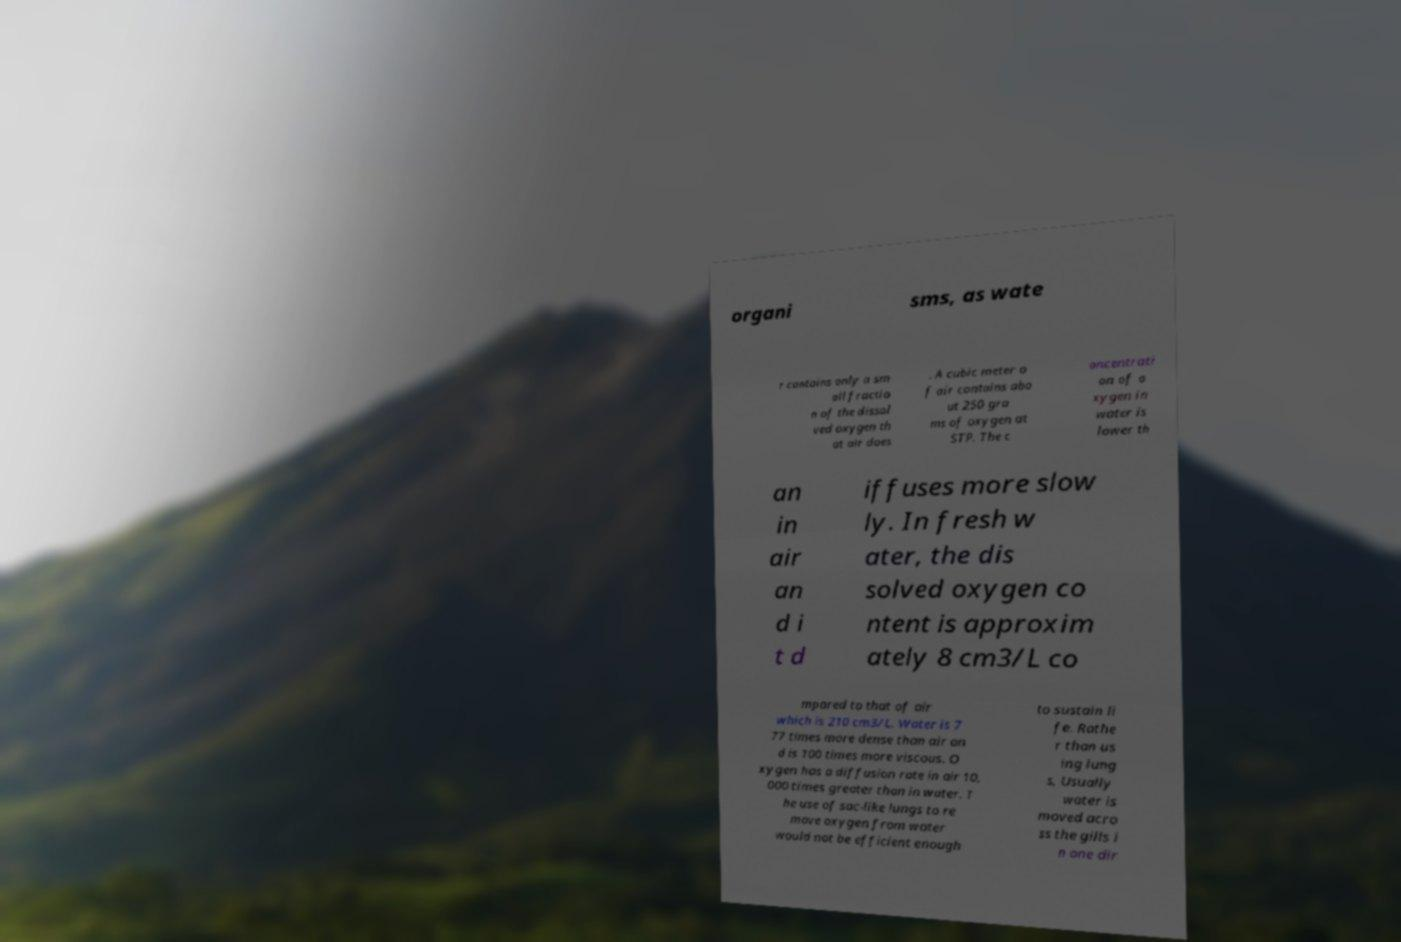There's text embedded in this image that I need extracted. Can you transcribe it verbatim? organi sms, as wate r contains only a sm all fractio n of the dissol ved oxygen th at air does . A cubic meter o f air contains abo ut 250 gra ms of oxygen at STP. The c oncentrati on of o xygen in water is lower th an in air an d i t d iffuses more slow ly. In fresh w ater, the dis solved oxygen co ntent is approxim ately 8 cm3/L co mpared to that of air which is 210 cm3/L. Water is 7 77 times more dense than air an d is 100 times more viscous. O xygen has a diffusion rate in air 10, 000 times greater than in water. T he use of sac-like lungs to re move oxygen from water would not be efficient enough to sustain li fe. Rathe r than us ing lung s, Usually water is moved acro ss the gills i n one dir 